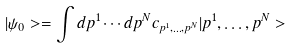Convert formula to latex. <formula><loc_0><loc_0><loc_500><loc_500>| \psi _ { 0 } > = \int d p ^ { 1 } \cdots d p ^ { N } c _ { p ^ { 1 } , \dots , p ^ { N } } | p ^ { 1 } , \dots , p ^ { N } ></formula> 